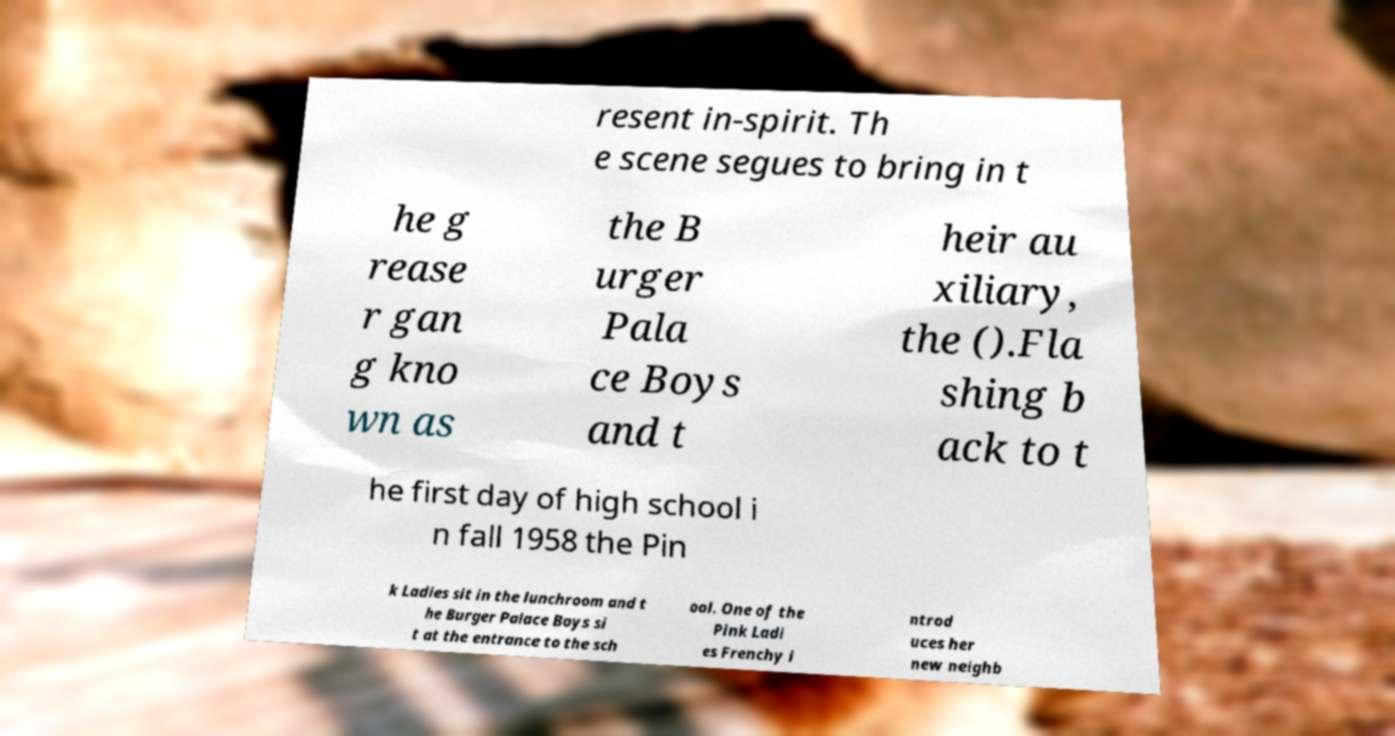I need the written content from this picture converted into text. Can you do that? resent in-spirit. Th e scene segues to bring in t he g rease r gan g kno wn as the B urger Pala ce Boys and t heir au xiliary, the ().Fla shing b ack to t he first day of high school i n fall 1958 the Pin k Ladies sit in the lunchroom and t he Burger Palace Boys si t at the entrance to the sch ool. One of the Pink Ladi es Frenchy i ntrod uces her new neighb 